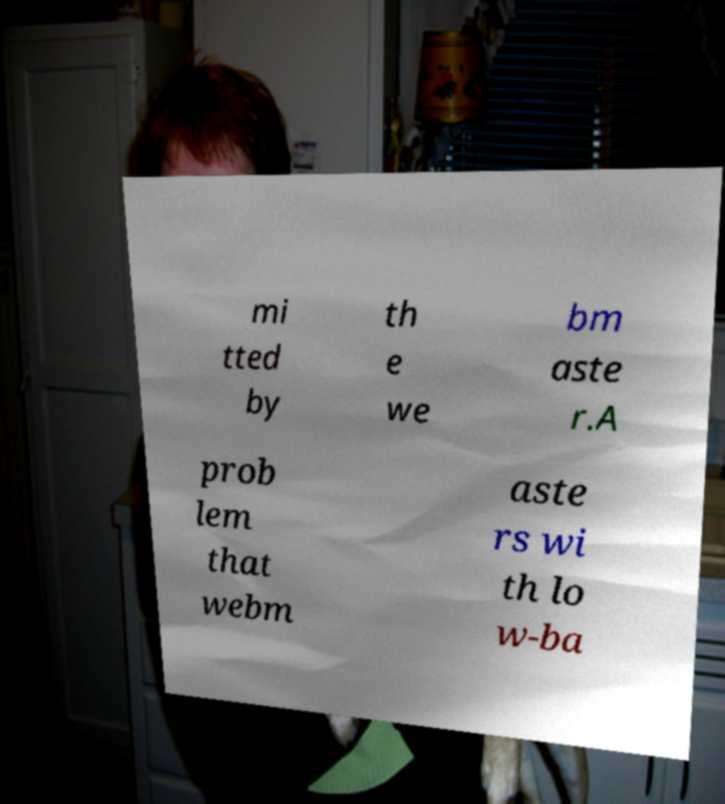There's text embedded in this image that I need extracted. Can you transcribe it verbatim? mi tted by th e we bm aste r.A prob lem that webm aste rs wi th lo w-ba 